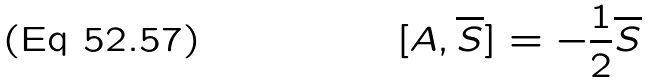Convert formula to latex. <formula><loc_0><loc_0><loc_500><loc_500>[ A , \overline { S } ] = - \frac { 1 } { 2 } \overline { S }</formula> 